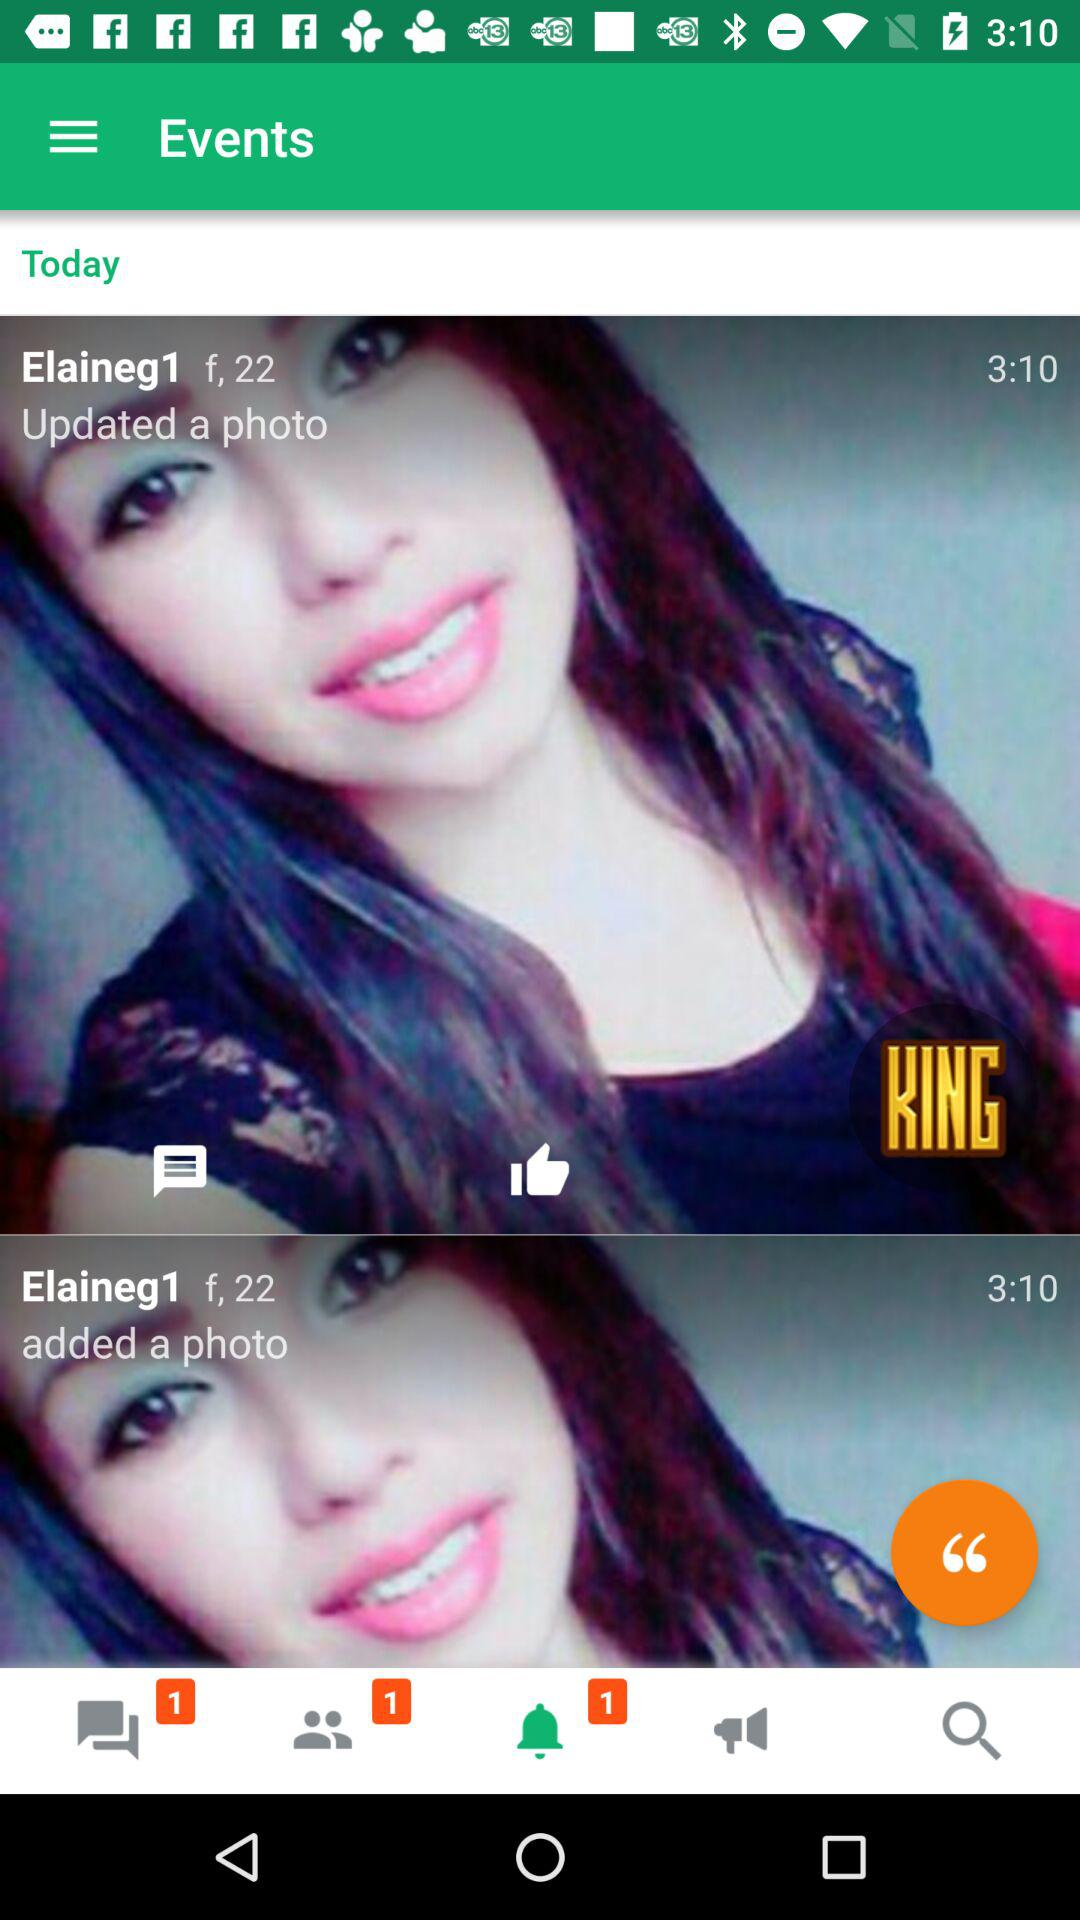How many new friend requests are there? There is 1 new friend request. 